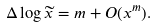<formula> <loc_0><loc_0><loc_500><loc_500>\Delta \log \widetilde { x } = m + O ( x ^ { m } ) .</formula> 